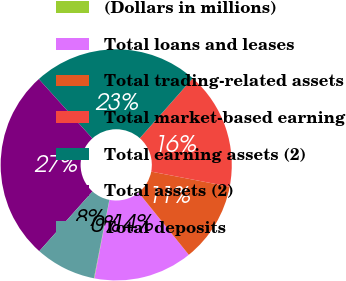Convert chart. <chart><loc_0><loc_0><loc_500><loc_500><pie_chart><fcel>(Dollars in millions)<fcel>Total loans and leases<fcel>Total trading-related assets<fcel>Total market-based earning<fcel>Total earning assets (2)<fcel>Total assets (2)<fcel>Total deposits<nl><fcel>0.07%<fcel>13.83%<fcel>11.17%<fcel>16.5%<fcel>23.2%<fcel>26.73%<fcel>8.5%<nl></chart> 